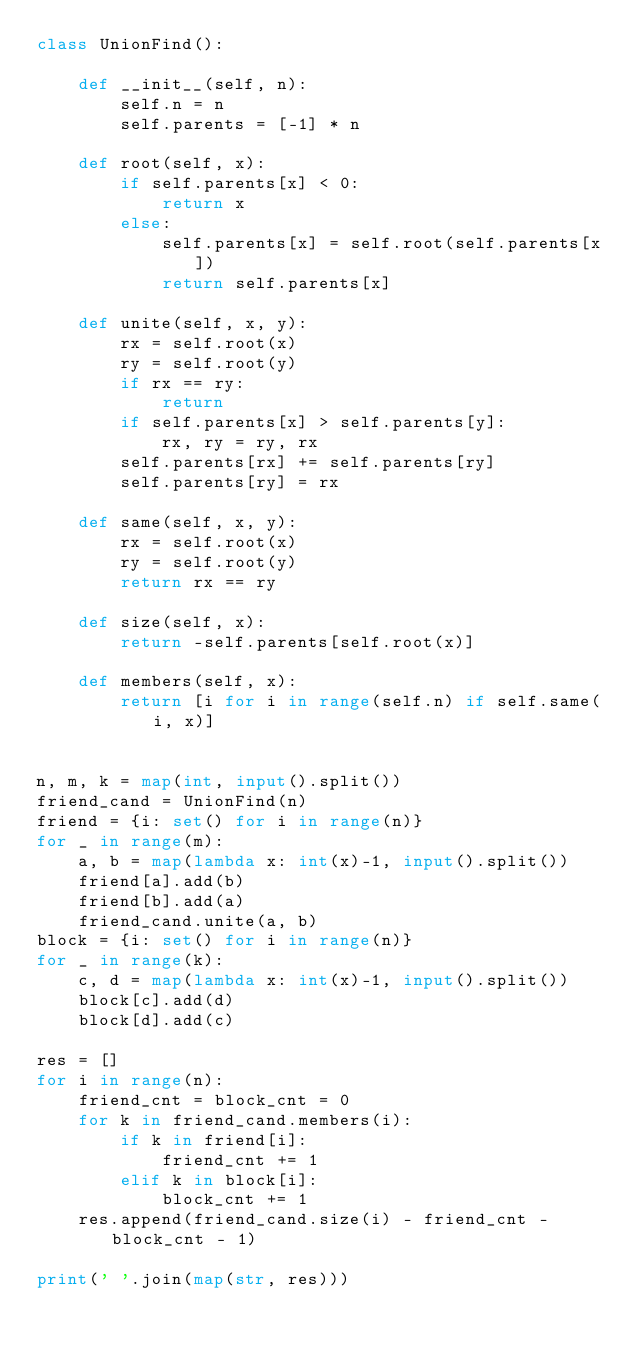<code> <loc_0><loc_0><loc_500><loc_500><_Python_>class UnionFind():

    def __init__(self, n):
        self.n = n
        self.parents = [-1] * n

    def root(self, x):
        if self.parents[x] < 0:
            return x
        else:
            self.parents[x] = self.root(self.parents[x])
            return self.parents[x]

    def unite(self, x, y):
        rx = self.root(x)
        ry = self.root(y)
        if rx == ry:
            return
        if self.parents[x] > self.parents[y]:
            rx, ry = ry, rx
        self.parents[rx] += self.parents[ry]
        self.parents[ry] = rx

    def same(self, x, y):
        rx = self.root(x)
        ry = self.root(y)
        return rx == ry

    def size(self, x):
        return -self.parents[self.root(x)]

    def members(self, x):
        return [i for i in range(self.n) if self.same(i, x)]


n, m, k = map(int, input().split())
friend_cand = UnionFind(n)
friend = {i: set() for i in range(n)}
for _ in range(m):
    a, b = map(lambda x: int(x)-1, input().split())
    friend[a].add(b)
    friend[b].add(a)
    friend_cand.unite(a, b)
block = {i: set() for i in range(n)}
for _ in range(k):
    c, d = map(lambda x: int(x)-1, input().split())
    block[c].add(d)
    block[d].add(c)

res = []
for i in range(n):
    friend_cnt = block_cnt = 0
    for k in friend_cand.members(i):
        if k in friend[i]:
            friend_cnt += 1
        elif k in block[i]:
            block_cnt += 1
    res.append(friend_cand.size(i) - friend_cnt - block_cnt - 1)

print(' '.join(map(str, res)))
</code> 